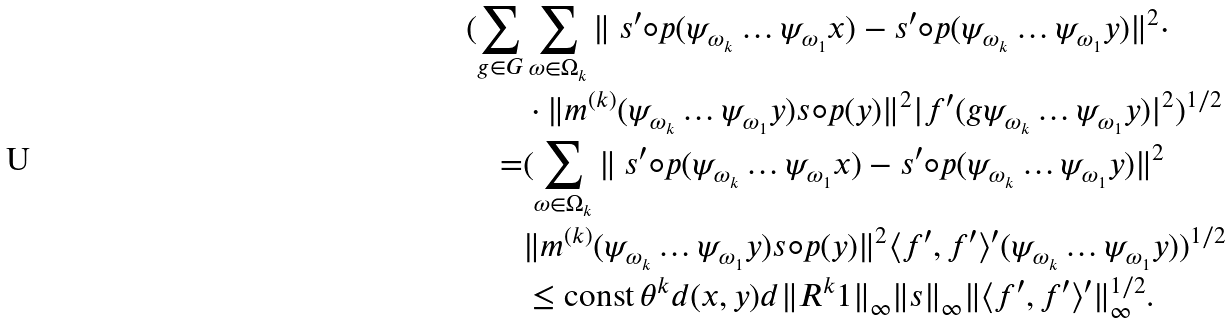<formula> <loc_0><loc_0><loc_500><loc_500>( \sum _ { g \in G } & \sum _ { \omega \in \Omega _ { k } } \| \ s ^ { \prime } \circ p ( \psi _ { \omega _ { k } } \dots \psi _ { \omega _ { 1 } } x ) - s ^ { \prime } \circ p ( \psi _ { \omega _ { k } } \dots \psi _ { \omega _ { 1 } } y ) \| ^ { 2 } \cdot \\ & \cdot \| m ^ { ( k ) } ( \psi _ { \omega _ { k } } \dots \psi _ { \omega _ { 1 } } y ) s \circ p ( y ) \| ^ { 2 } | f ^ { \prime } ( g \psi _ { \omega _ { k } } \dots \psi _ { \omega _ { 1 } } y ) | ^ { 2 } ) ^ { 1 / 2 } \\ = & ( \sum _ { \omega \in \Omega _ { k } } \| \ s ^ { \prime } \circ p ( \psi _ { \omega _ { k } } \dots \psi _ { \omega _ { 1 } } x ) - s ^ { \prime } \circ p ( \psi _ { \omega _ { k } } \dots \psi _ { \omega _ { 1 } } y ) \| ^ { 2 } \\ & \| m ^ { ( k ) } ( \psi _ { \omega _ { k } } \dots \psi _ { \omega _ { 1 } } y ) s \circ p ( y ) \| ^ { 2 } \langle f ^ { \prime } , f ^ { \prime } \rangle ^ { \prime } ( \psi _ { \omega _ { k } } \dots \psi _ { \omega _ { 1 } } y ) ) ^ { 1 / 2 } \\ & \leq \text {const} \, \theta ^ { k } d ( x , y ) d \| R ^ { k } 1 \| _ { \infty } \| s \| _ { \infty } \| \langle f ^ { \prime } , f ^ { \prime } \rangle ^ { \prime } \| _ { \infty } ^ { 1 / 2 } .</formula> 